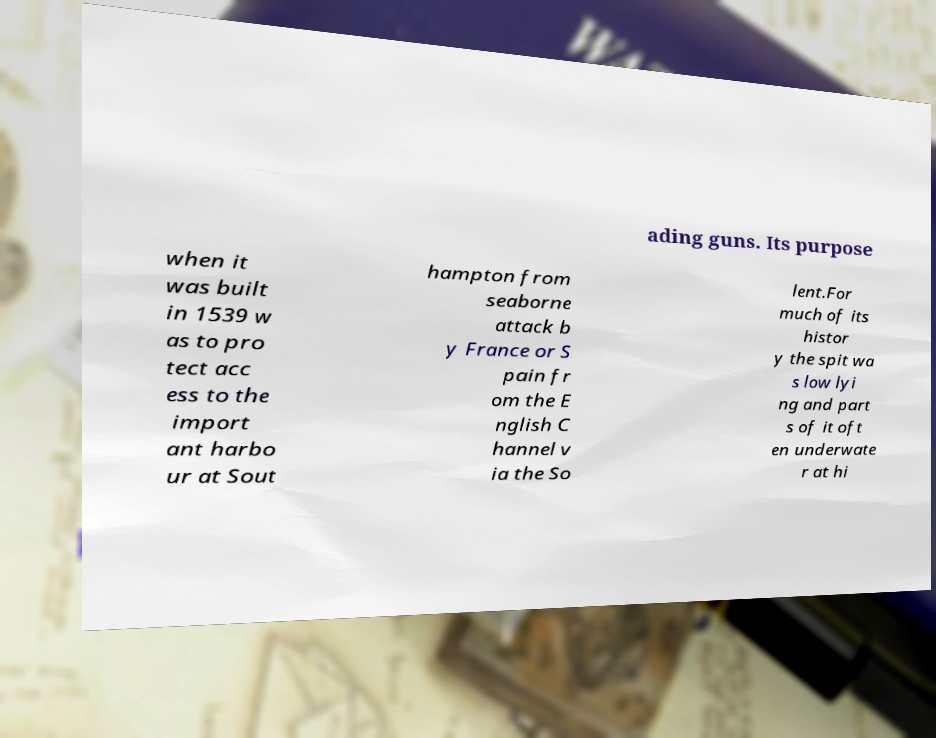There's text embedded in this image that I need extracted. Can you transcribe it verbatim? ading guns. Its purpose when it was built in 1539 w as to pro tect acc ess to the import ant harbo ur at Sout hampton from seaborne attack b y France or S pain fr om the E nglish C hannel v ia the So lent.For much of its histor y the spit wa s low lyi ng and part s of it oft en underwate r at hi 